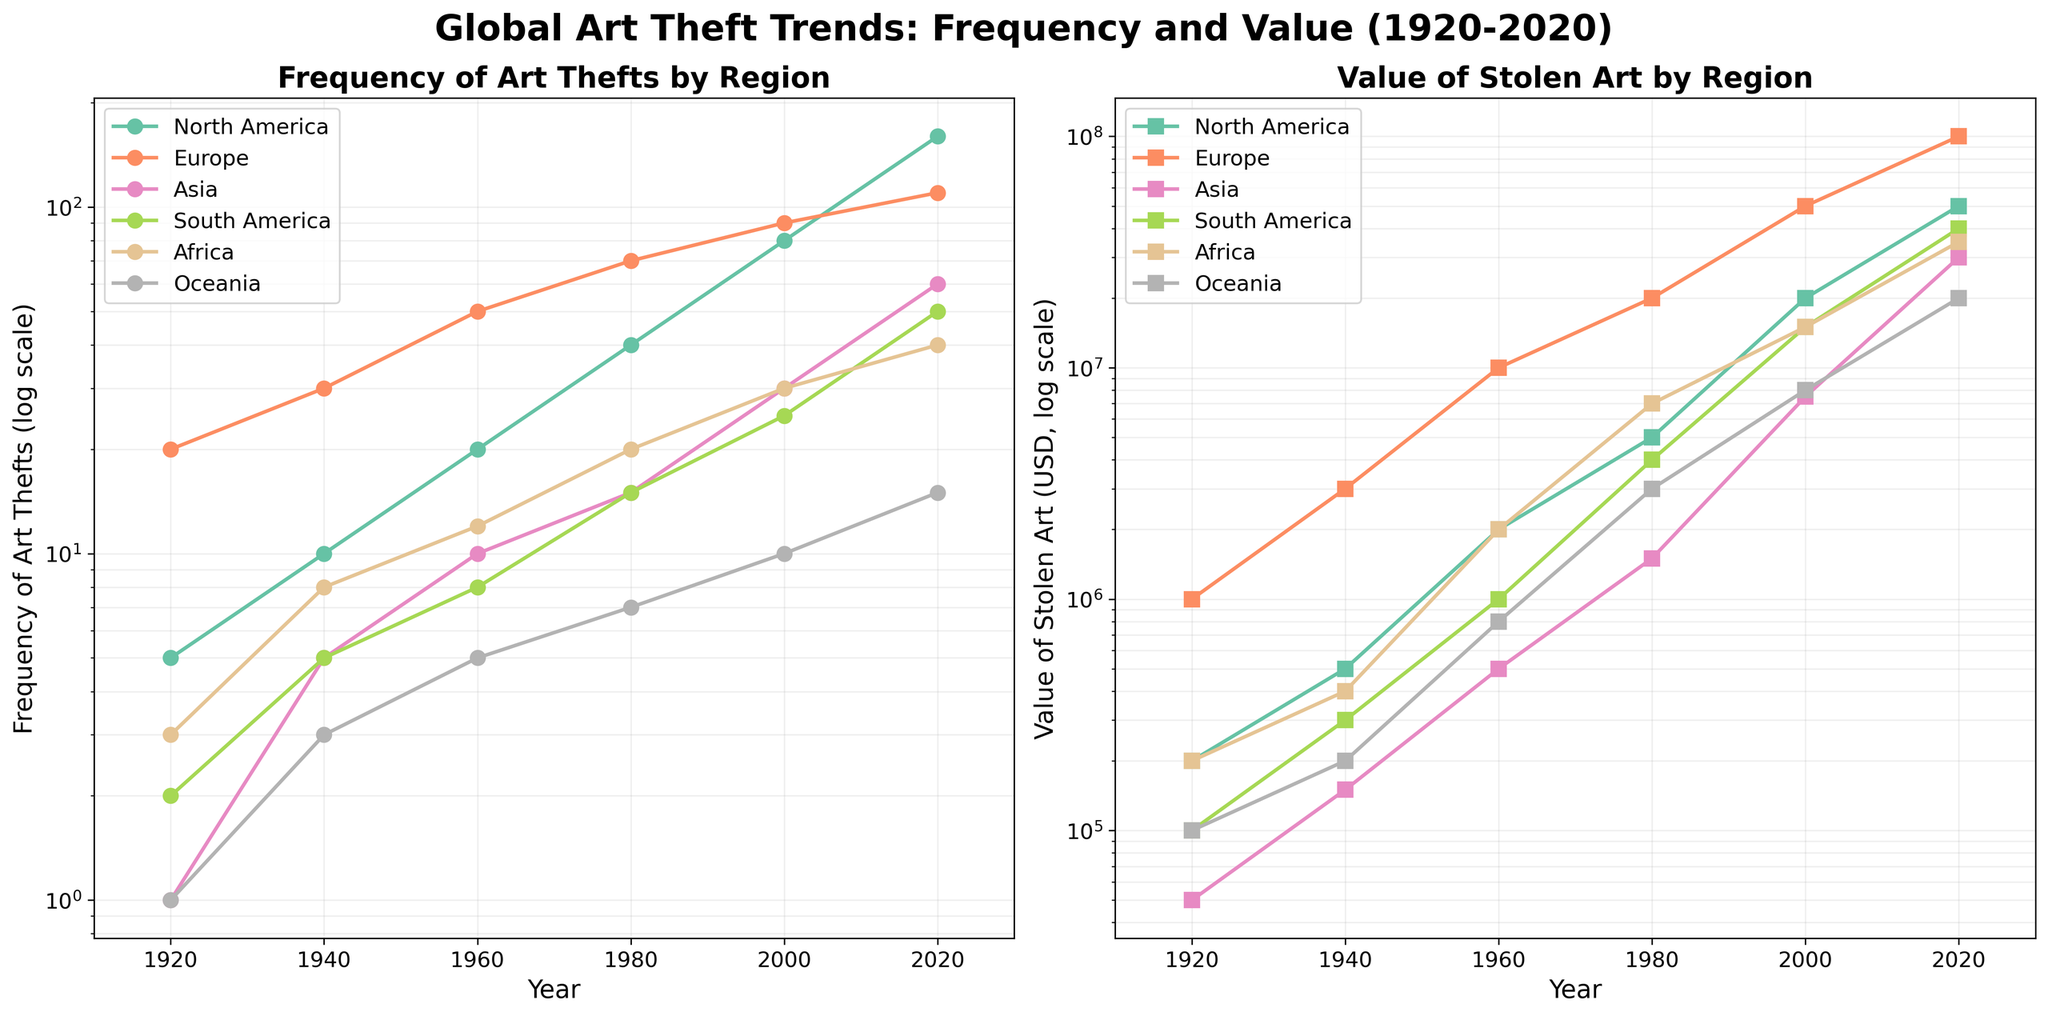What's the title of the figure? The title of the figure is positioned at the top and is often displayed in a larger and bold font for emphasis. Here, it reads "Global Art Theft Trends: Frequency and Value (1920-2020)".
Answer: Global Art Theft Trends: Frequency and Value (1920-2020) Which region shows the highest frequency of art thefts in 2020? To determine this, first locate the year 2020 on the x-axis of the left subplot. Then, compare the y-values (frequency of art thefts) for all regions at this year. The region with the highest point is North America.
Answer: North America Between which years did Europe see the most significant increase in the value of stolen art? Identify the Europe data line in the right subplot and check the y-values over the years. The most significant increase occurs between points where the line has the steepest slope, which is between 2000 and 2020.
Answer: 2000 and 2020 How does the frequency of art thefts in Asia in 1980 compare to 1960? Locate the data points for 1980 and 1960 on the left subplot for Asia. In 1960, the frequency is at 10, while in 1980 it is at 15, indicating an increase.
Answer: 15 vs. 10 What is the value of stolen art in South America in 1920 and 2020? On the right subplot, locate the data points for South America in the years 1920 and 2020. The values are $100,000 in 1920 and $40,000,000 in 2020.
Answer: $100,000 and $40,000,000 Which region had the least variation in art theft frequency over the century? Analyze the left subplot, focusing on the slopes of the lines. The line with the smallest changes indicates the least variation. Oceania shows a relatively steady increase, implying the least variation.
Answer: Oceania How many data points are plotted for Africa for the value of stolen art? Observe the right subplot, tracing the number of plotted points corresponding to Africa. There are six data points, corresponding to each decade from 1920 to 2020.
Answer: 6 What pattern do you observe in the frequency of art thefts in North America? Examine the left subplot for North America. The frequency grows exponentially with each decade, indicating a continually increasing trend.
Answer: Exponential increase Which region shows a more rapid growth in the value of stolen art from 2000 to 2020: Asia or Africa? Compare the slopes of the lines for Asia and Africa on the right subplot from 2000 to 2020. Asia shows a steeper slope, indicating a more rapid growth.
Answer: Asia 